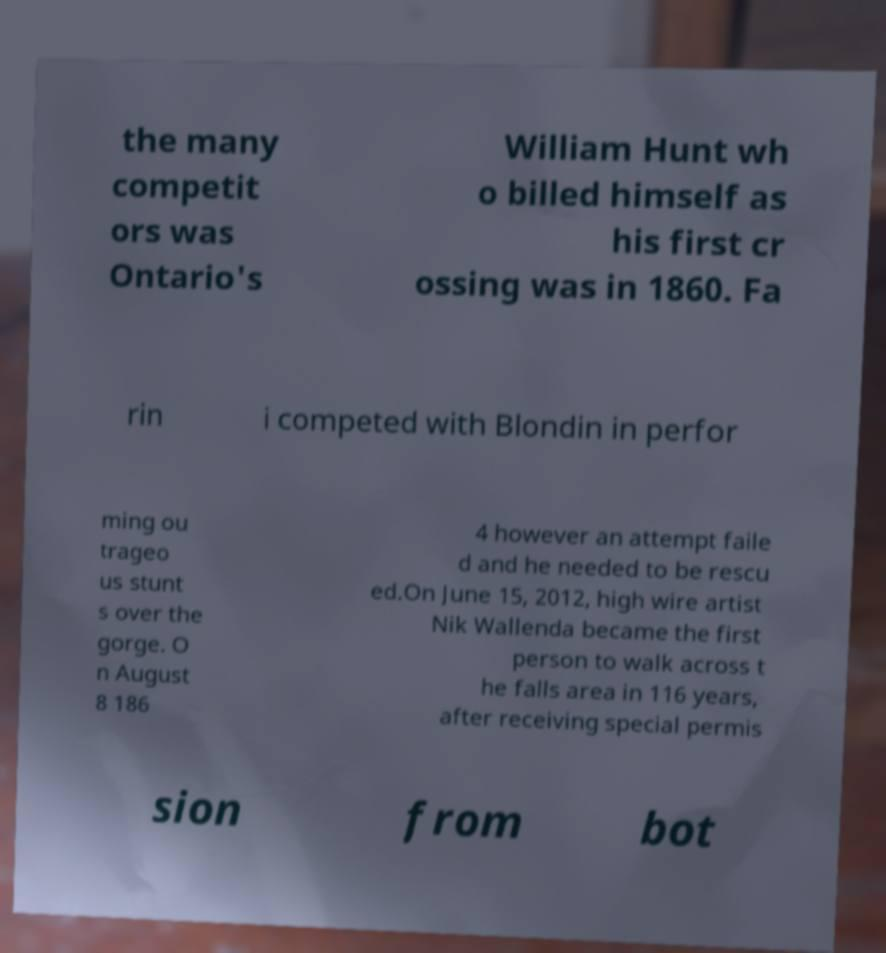Please identify and transcribe the text found in this image. the many competit ors was Ontario's William Hunt wh o billed himself as his first cr ossing was in 1860. Fa rin i competed with Blondin in perfor ming ou trageo us stunt s over the gorge. O n August 8 186 4 however an attempt faile d and he needed to be rescu ed.On June 15, 2012, high wire artist Nik Wallenda became the first person to walk across t he falls area in 116 years, after receiving special permis sion from bot 